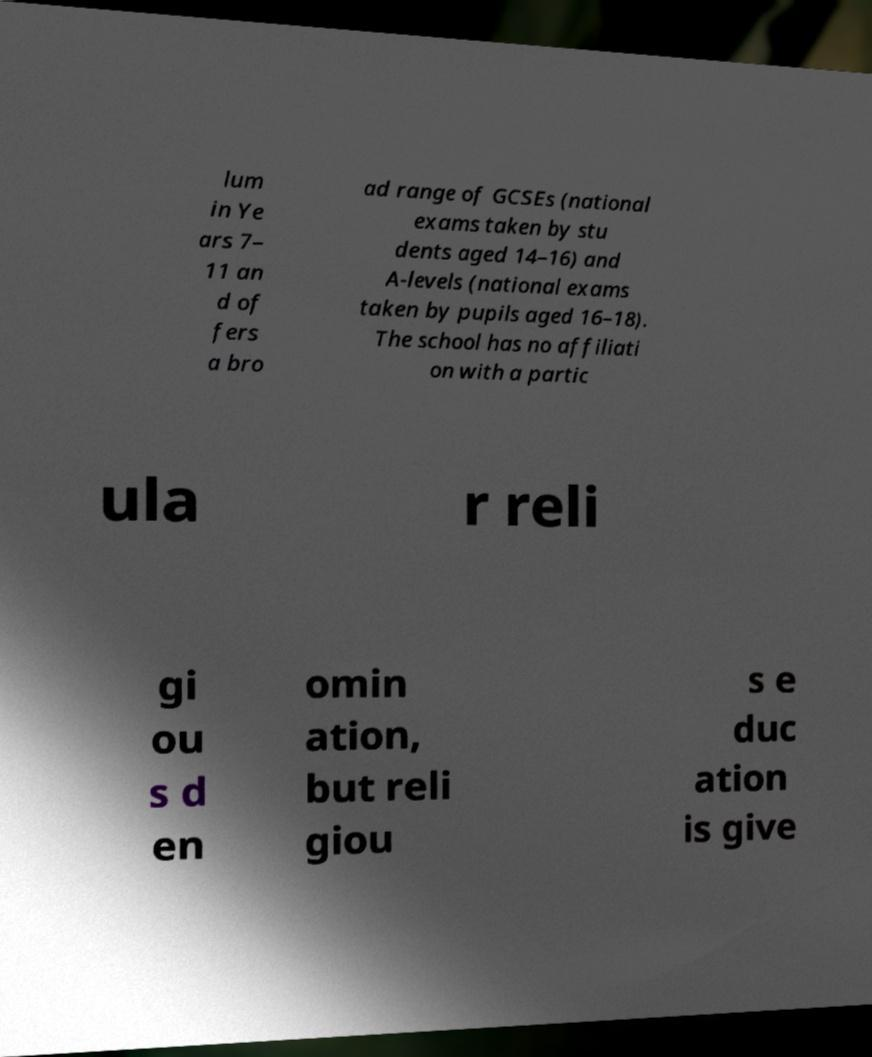Can you read and provide the text displayed in the image?This photo seems to have some interesting text. Can you extract and type it out for me? lum in Ye ars 7– 11 an d of fers a bro ad range of GCSEs (national exams taken by stu dents aged 14–16) and A-levels (national exams taken by pupils aged 16–18). The school has no affiliati on with a partic ula r reli gi ou s d en omin ation, but reli giou s e duc ation is give 